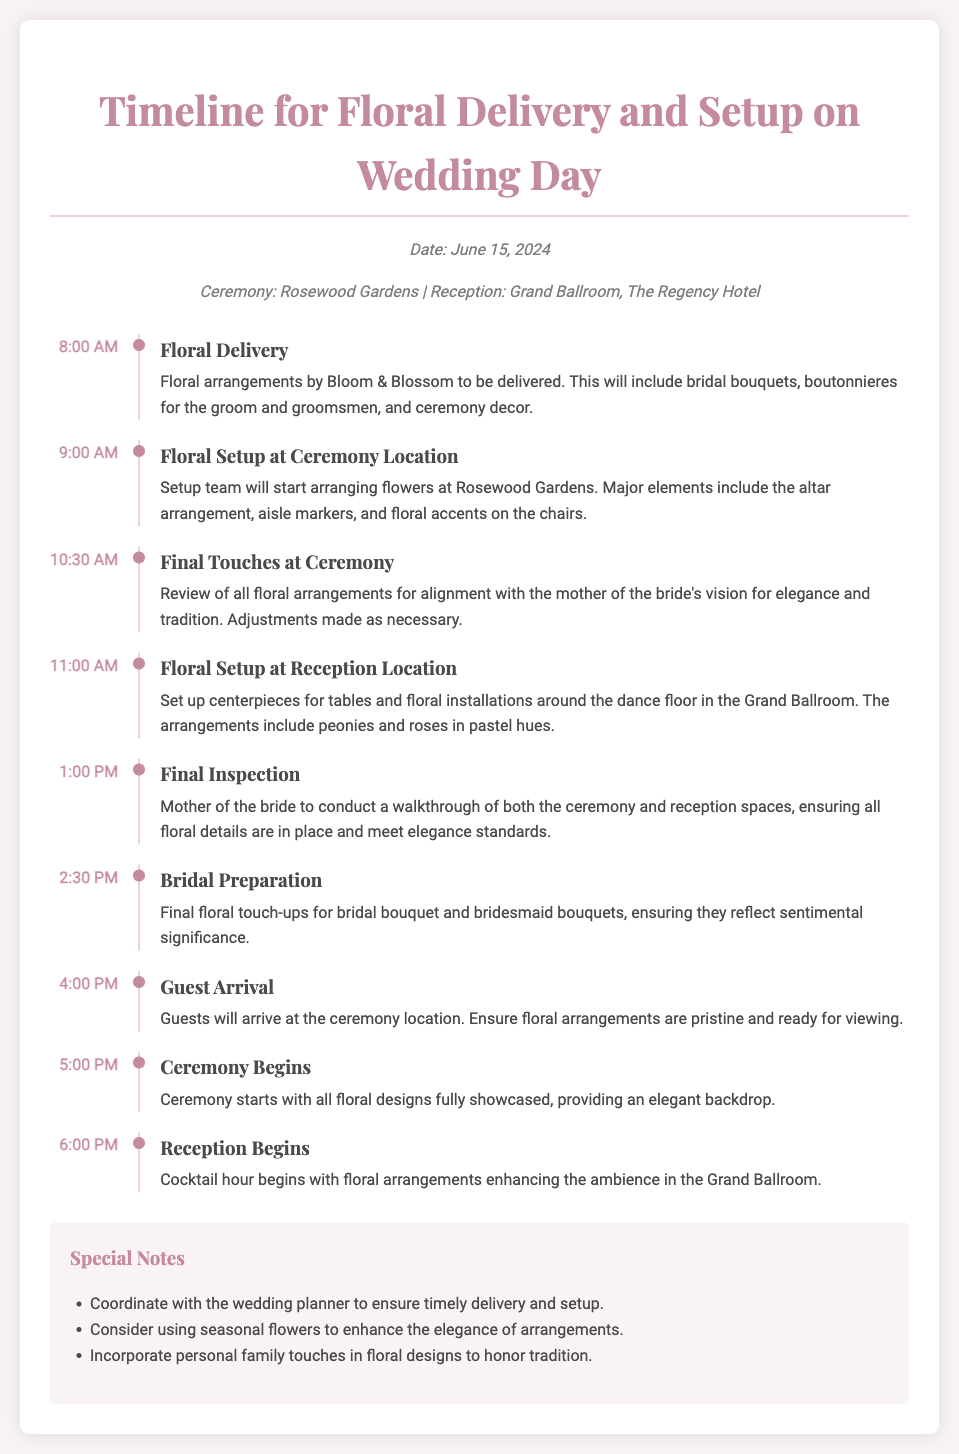What is the date of the wedding? The date of the wedding is specified at the top of the document.
Answer: June 15, 2024 What is the ceremony location? The ceremony location is mentioned in the document.
Answer: Rosewood Gardens What is the reception location? The reception location is provided in the details of the document.
Answer: Grand Ballroom, The Regency Hotel What time does floral delivery start? The timeline specifies the start time for floral delivery.
Answer: 8:00 AM What must be conducted at 1:00 PM? The timeline indicates an inspection to be held at this time.
Answer: Final Inspection What is included in the floral delivery? This question asks for specifics about the items delivered.
Answer: Bridal bouquets, boutonnieres, ceremony decor What floral elements are set up at the ceremony location? The document lists specific floral elements that need to be arranged.
Answer: Altar arrangement, aisle markers, floral accents on chairs What is the main purpose of the floral arrangements during the ceremony? This question examines the significance of floral arrangements based on provided details.
Answer: To provide an elegant backdrop Which flowers are mentioned for the reception centerpieces? This asks for specific flower types included in the reception.
Answer: Peonies and roses in pastel hues Why should personal family touches be incorporated into floral designs? This requires reasoning about the sentiment behind the arrangements.
Answer: To honor tradition 